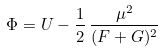Convert formula to latex. <formula><loc_0><loc_0><loc_500><loc_500>\Phi = U - \frac { 1 } { 2 } \, \frac { \mu ^ { 2 } } { ( F + G ) ^ { 2 } }</formula> 